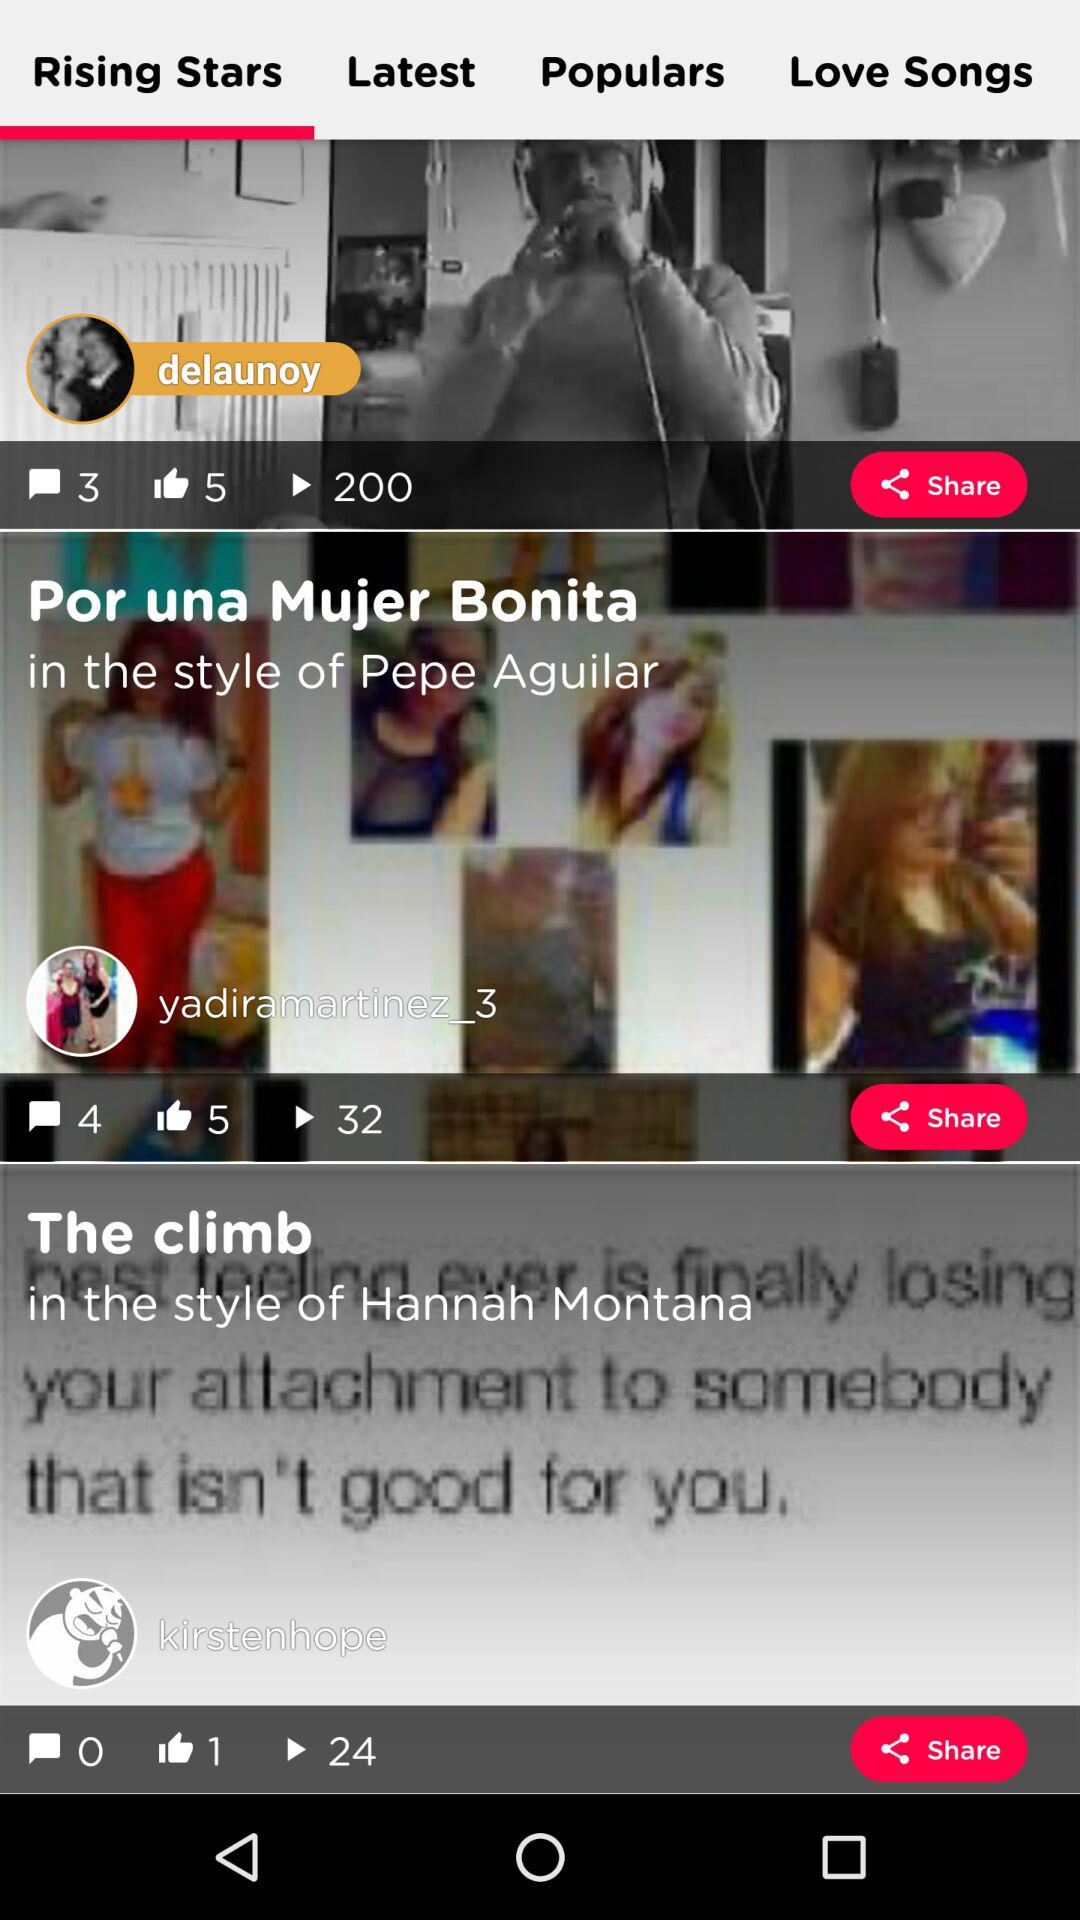Which tab is selected? The selected tab is "Rising Stars". 